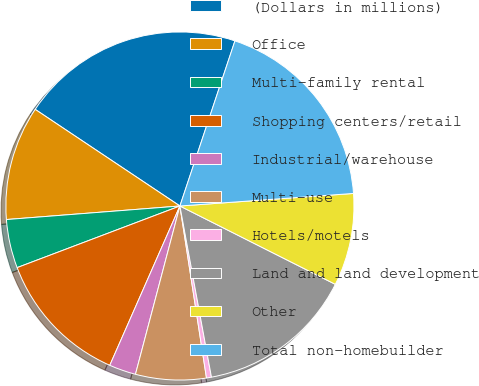Convert chart to OTSL. <chart><loc_0><loc_0><loc_500><loc_500><pie_chart><fcel>(Dollars in millions)<fcel>Office<fcel>Multi-family rental<fcel>Shopping centers/retail<fcel>Industrial/warehouse<fcel>Multi-use<fcel>Hotels/motels<fcel>Land and land development<fcel>Other<fcel>Total non-homebuilder<nl><fcel>20.75%<fcel>10.61%<fcel>4.52%<fcel>12.64%<fcel>2.49%<fcel>6.55%<fcel>0.46%<fcel>14.67%<fcel>8.58%<fcel>18.73%<nl></chart> 